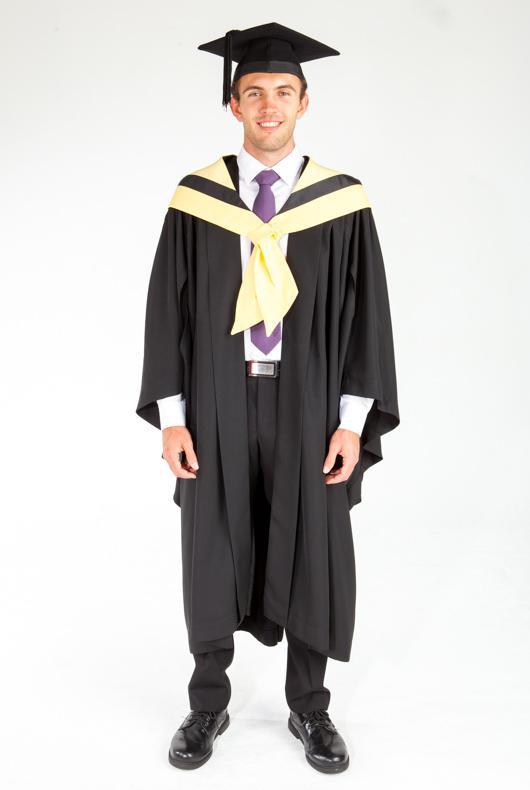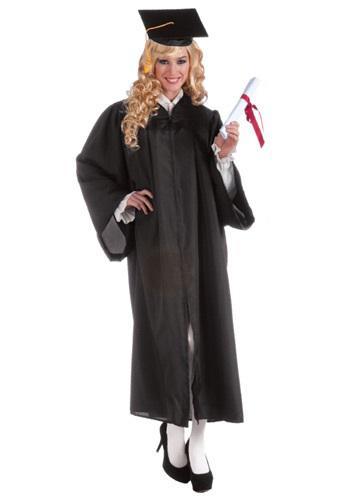The first image is the image on the left, the second image is the image on the right. Examine the images to the left and right. Is the description "There is a female in the right image." accurate? Answer yes or no. Yes. The first image is the image on the left, the second image is the image on the right. Considering the images on both sides, is "There is a man on the left and a woman on the right in both images." valid? Answer yes or no. Yes. 